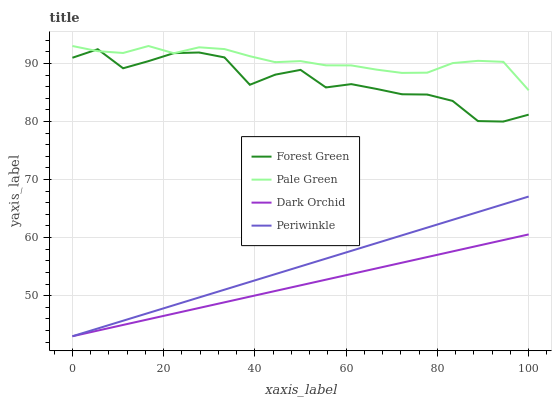Does Dark Orchid have the minimum area under the curve?
Answer yes or no. Yes. Does Pale Green have the maximum area under the curve?
Answer yes or no. Yes. Does Periwinkle have the minimum area under the curve?
Answer yes or no. No. Does Periwinkle have the maximum area under the curve?
Answer yes or no. No. Is Periwinkle the smoothest?
Answer yes or no. Yes. Is Forest Green the roughest?
Answer yes or no. Yes. Is Pale Green the smoothest?
Answer yes or no. No. Is Pale Green the roughest?
Answer yes or no. No. Does Periwinkle have the lowest value?
Answer yes or no. Yes. Does Pale Green have the lowest value?
Answer yes or no. No. Does Pale Green have the highest value?
Answer yes or no. Yes. Does Periwinkle have the highest value?
Answer yes or no. No. Is Dark Orchid less than Pale Green?
Answer yes or no. Yes. Is Pale Green greater than Periwinkle?
Answer yes or no. Yes. Does Pale Green intersect Forest Green?
Answer yes or no. Yes. Is Pale Green less than Forest Green?
Answer yes or no. No. Is Pale Green greater than Forest Green?
Answer yes or no. No. Does Dark Orchid intersect Pale Green?
Answer yes or no. No. 